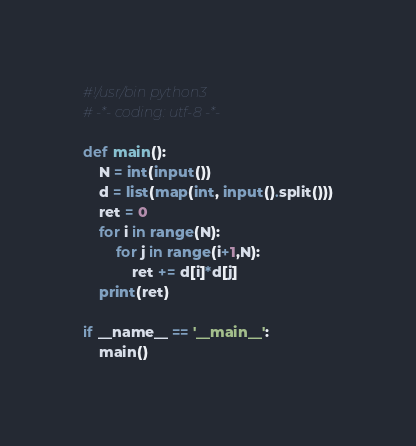<code> <loc_0><loc_0><loc_500><loc_500><_Python_>#!/usr/bin python3
# -*- coding: utf-8 -*-

def main():
    N = int(input())
    d = list(map(int, input().split()))
    ret = 0
    for i in range(N):
        for j in range(i+1,N):
            ret += d[i]*d[j]
    print(ret)

if __name__ == '__main__':
    main()</code> 